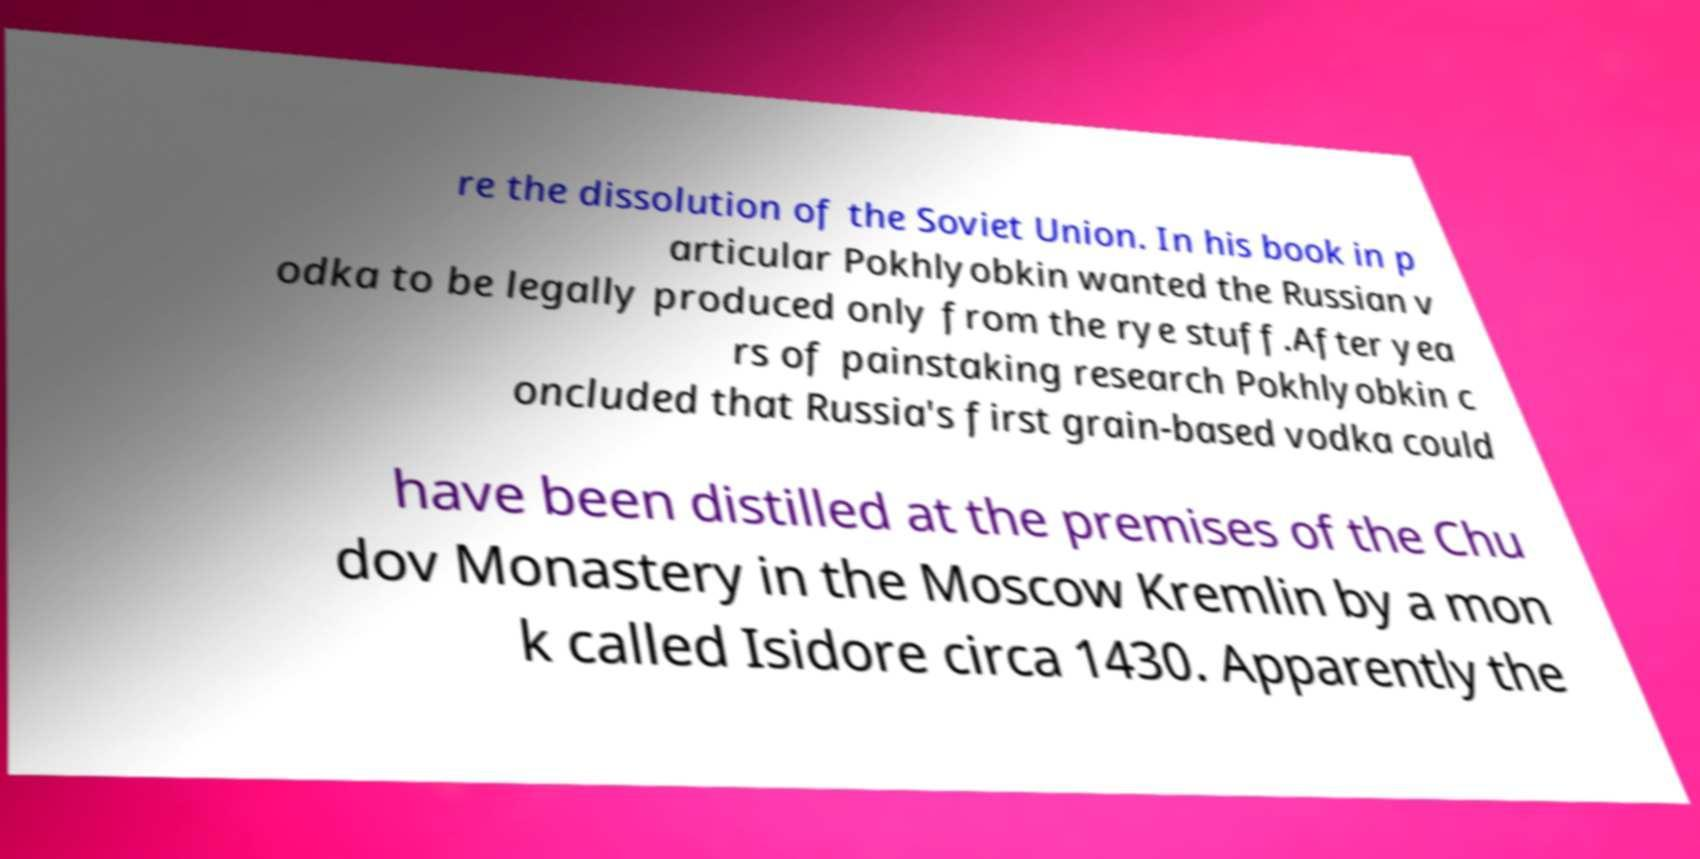Please read and relay the text visible in this image. What does it say? re the dissolution of the Soviet Union. In his book in p articular Pokhlyobkin wanted the Russian v odka to be legally produced only from the rye stuff.After yea rs of painstaking research Pokhlyobkin c oncluded that Russia's first grain-based vodka could have been distilled at the premises of the Chu dov Monastery in the Moscow Kremlin by a mon k called Isidore circa 1430. Apparently the 